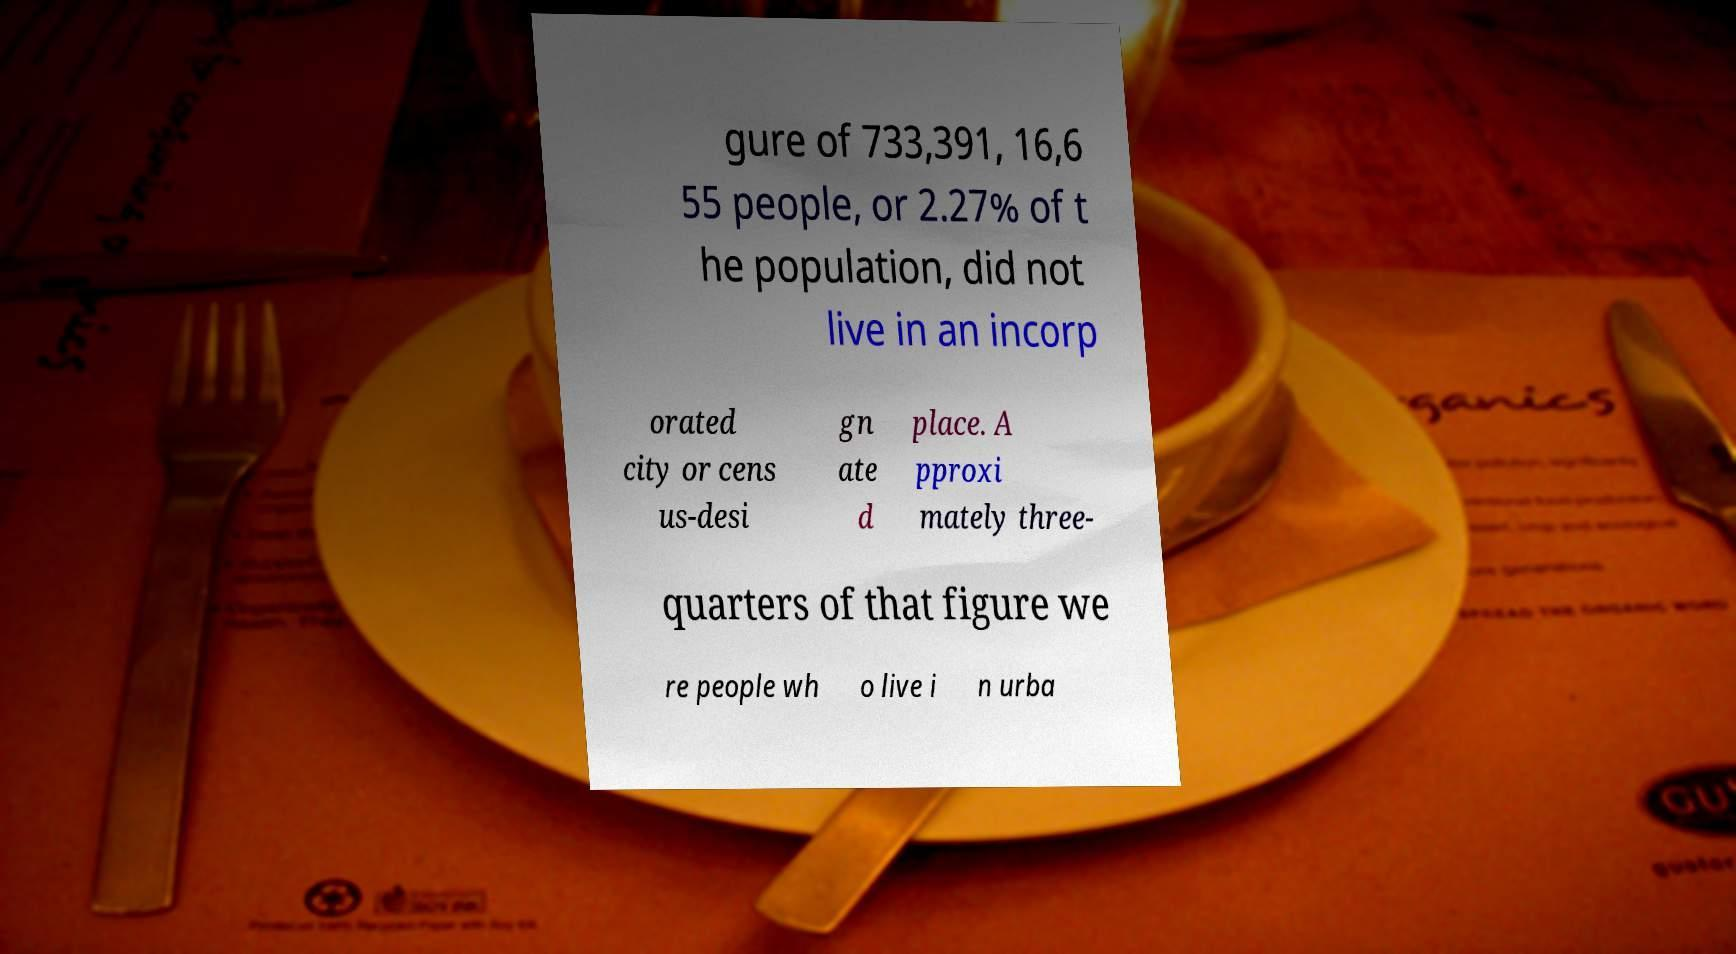There's text embedded in this image that I need extracted. Can you transcribe it verbatim? gure of 733,391, 16,6 55 people, or 2.27% of t he population, did not live in an incorp orated city or cens us-desi gn ate d place. A pproxi mately three- quarters of that figure we re people wh o live i n urba 